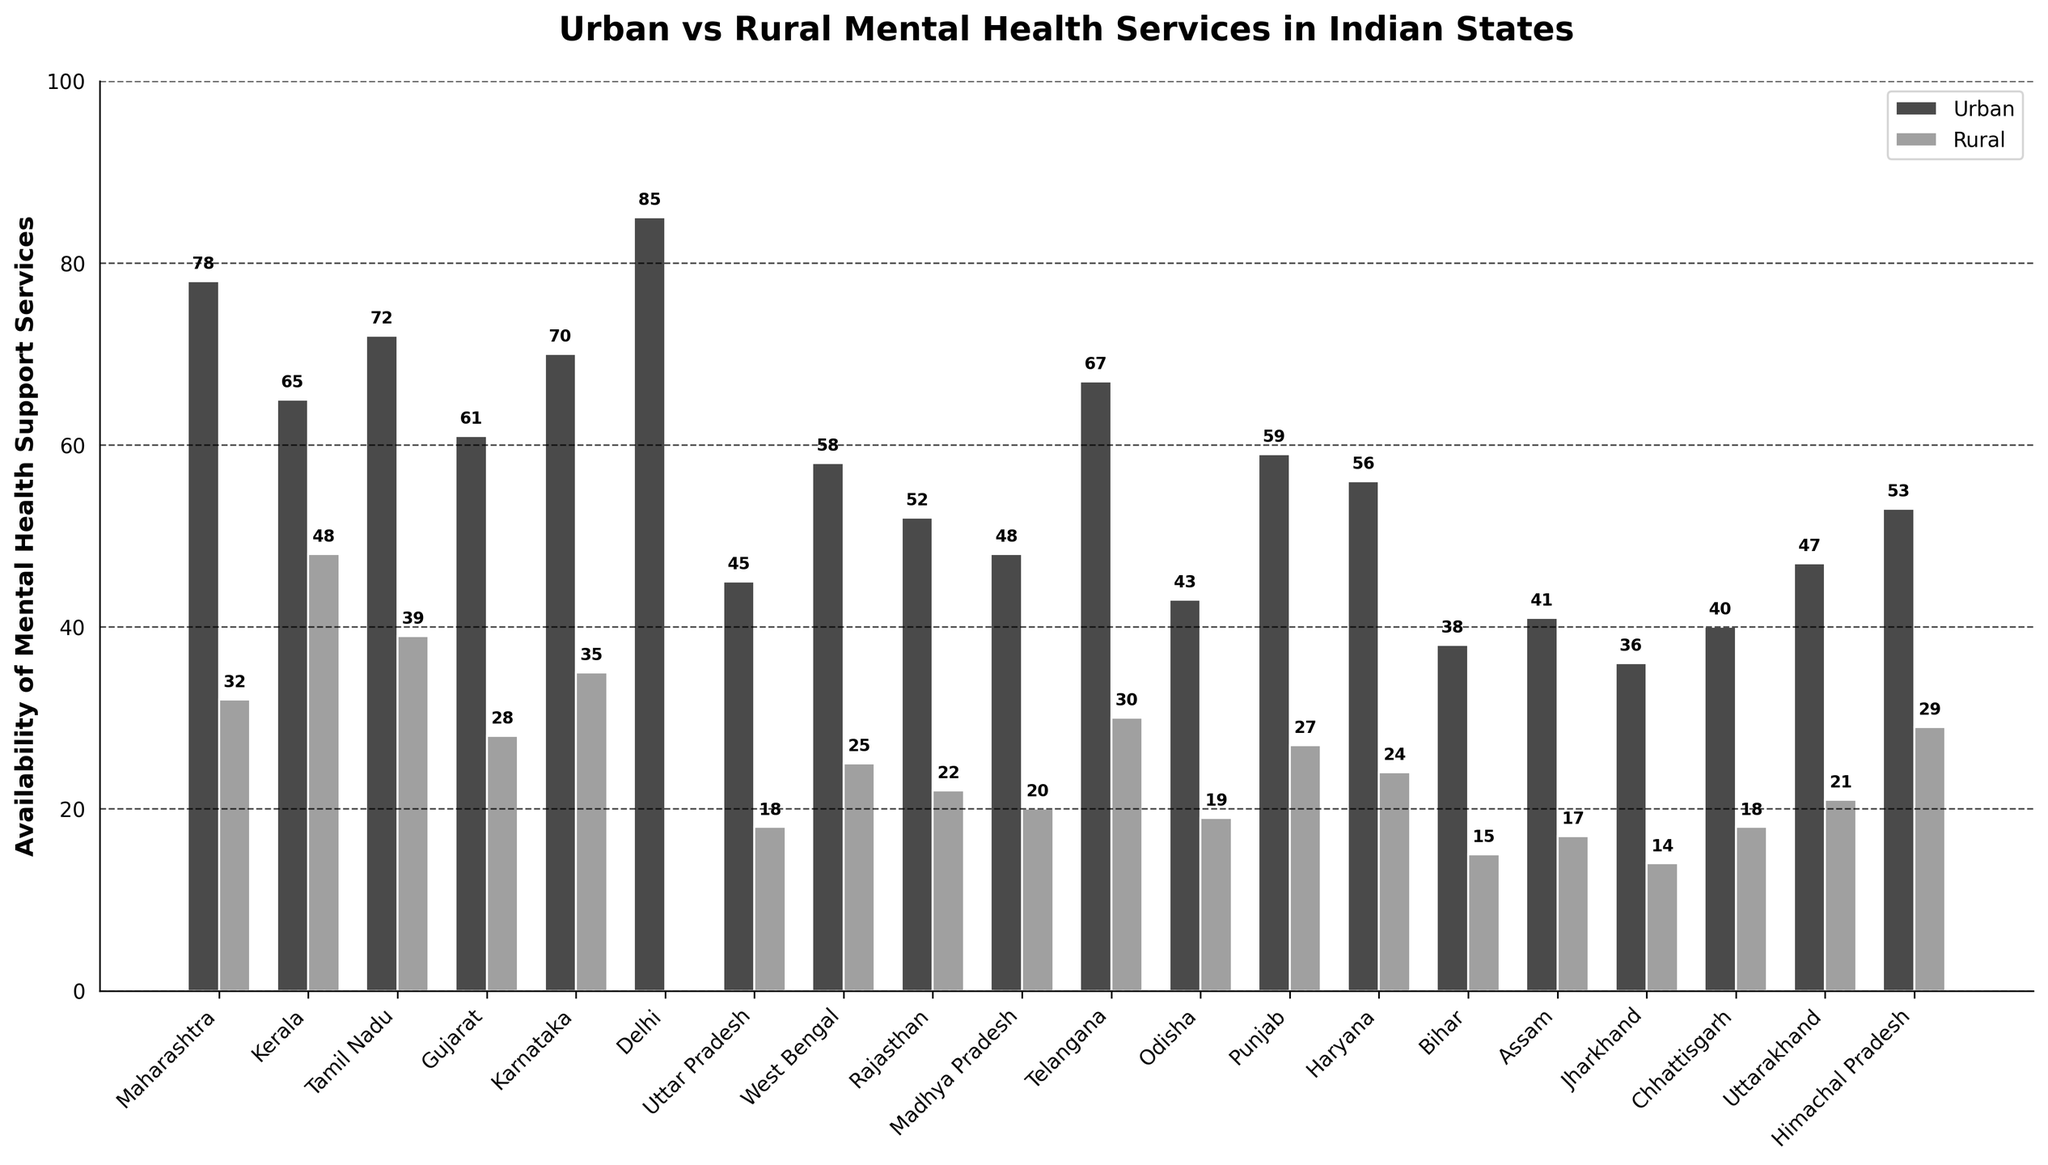Which state has the highest availability of urban mental health services? Looking at the figure, the tallest bar in the 'Urban' category corresponds to Delhi, indicating it's the state with the highest availability of urban mental health services.
Answer: Delhi Which state has the lowest availability of rural mental health services? The shortest bar in the 'Rural' category is for Jharkhand, which means it has the lowest availability of rural mental health services.
Answer: Jharkhand What's the difference between urban and rural mental health support services in Tamil Nadu? In the figure, the urban bar for Tamil Nadu is at 72 and the rural bar is at 39. Calculating the difference, 72 - 39 = 33.
Answer: 33 Which state has a bigger gap between urban and rural services, Karnataka or Kerala? Karnataka has urban services at 70 and rural services at 35, resulting in a gap of 70 - 35 = 35. Kerala has urban services at 65 and rural services at 48, resulting in a gap of 65 - 48 = 17. Comparing both gaps, Karnataka has a bigger gap.
Answer: Karnataka In which state are urban mental health services less than twice the rural mental health services? We need to check for each state where 2 * Rural > Urban. For example, in Uttar Pradesh, rural services are 18, twice of which is 36, and urban services are 45. So 45 < 36 is false. Going through each state, Kerala (2 * 48 > 65, thus true) fits the condition.
Answer: Kerala What is the average availability of urban mental health services across all states? Summing up the urban values: 78 + 65 + 72 + 61 + 70 + 85 + 45 + 58 + 52 + 48 + 67 + 43 + 59 + 56 + 38 + 41 + 36 + 40 + 47 + 53 = 1115. Dividing by the number of entries (20), avg = 1115 / 20 = 55.75.
Answer: 55.75 Comparing Maharashtra and Gujarat, which state has more rural mental health services? The rural bar for Maharashtra is at 32 while for Gujarat it is at 28, making Maharashtra have more rural mental health services than Gujarat.
Answer: Maharashtra What is the sum of urban services for Uttar Pradesh, Odisha, and Punjab? Urban services for Uttar Pradesh is 45, for Odisha is 43, and for Punjab is 59. So, the sum is 45 + 43 + 59 = 147.
Answer: 147 Which state has the smallest gap between urban and rural mental health services? Calculating the gaps for all states, Kerala has the smallest gap as (65 - 48 = 17) which is the smallest among all gaps.
Answer: Kerala Does any state have an equal number of urban and rural mental health services? From the figure, no bars for urban and rural mental health services are of equal height for any state, implying there is no state with equal urban and rural services.
Answer: No 